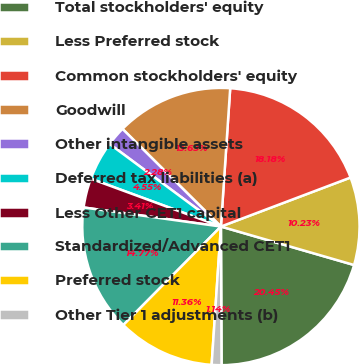<chart> <loc_0><loc_0><loc_500><loc_500><pie_chart><fcel>Total stockholders' equity<fcel>Less Preferred stock<fcel>Common stockholders' equity<fcel>Goodwill<fcel>Other intangible assets<fcel>Deferred tax liabilities (a)<fcel>Less Other CET1 capital<fcel>Standardized/Advanced CET1<fcel>Preferred stock<fcel>Other Tier 1 adjustments (b)<nl><fcel>20.45%<fcel>10.23%<fcel>18.18%<fcel>13.63%<fcel>2.28%<fcel>4.55%<fcel>3.41%<fcel>14.77%<fcel>11.36%<fcel>1.14%<nl></chart> 